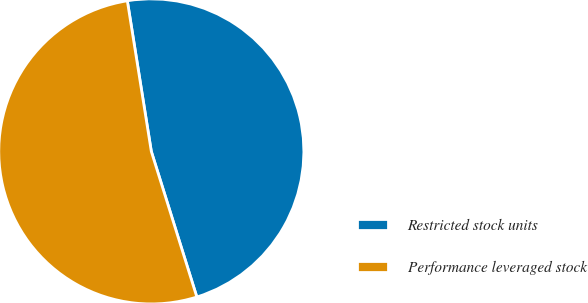<chart> <loc_0><loc_0><loc_500><loc_500><pie_chart><fcel>Restricted stock units<fcel>Performance leveraged stock<nl><fcel>47.69%<fcel>52.31%<nl></chart> 